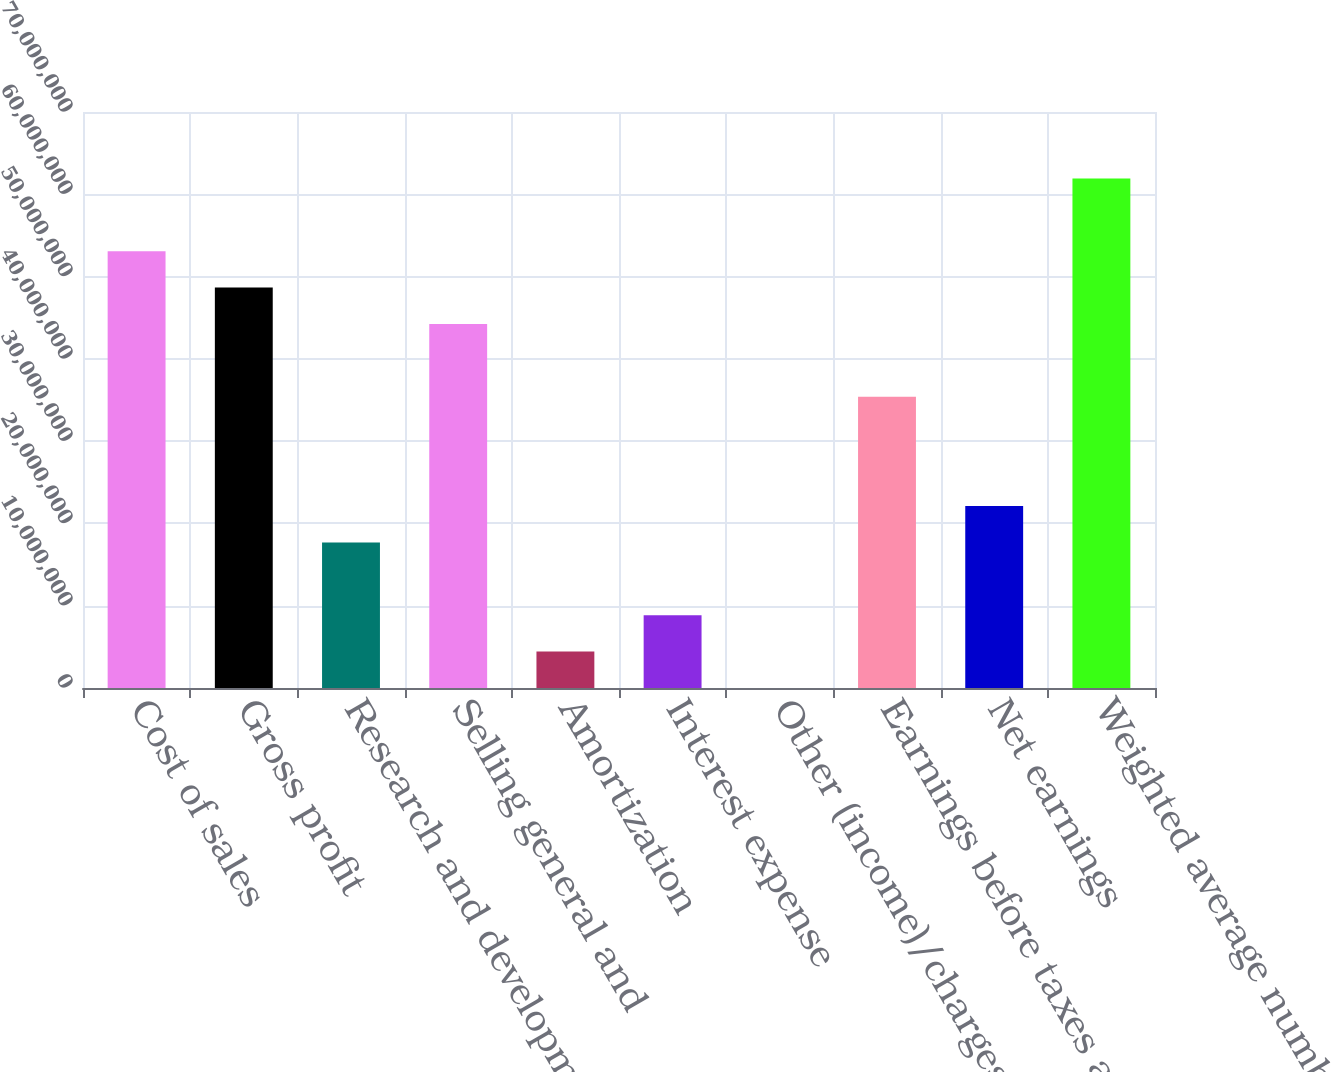Convert chart to OTSL. <chart><loc_0><loc_0><loc_500><loc_500><bar_chart><fcel>Cost of sales<fcel>Gross profit<fcel>Research and development<fcel>Selling general and<fcel>Amortization<fcel>Interest expense<fcel>Other (income)/charges net (a)<fcel>Earnings before taxes and<fcel>Net earnings<fcel>Weighted average number of<nl><fcel>5.30846e+07<fcel>4.86609e+07<fcel>1.76949e+07<fcel>4.42372e+07<fcel>4.42376e+06<fcel>8.84748e+06<fcel>42<fcel>3.53898e+07<fcel>2.21186e+07<fcel>6.19321e+07<nl></chart> 